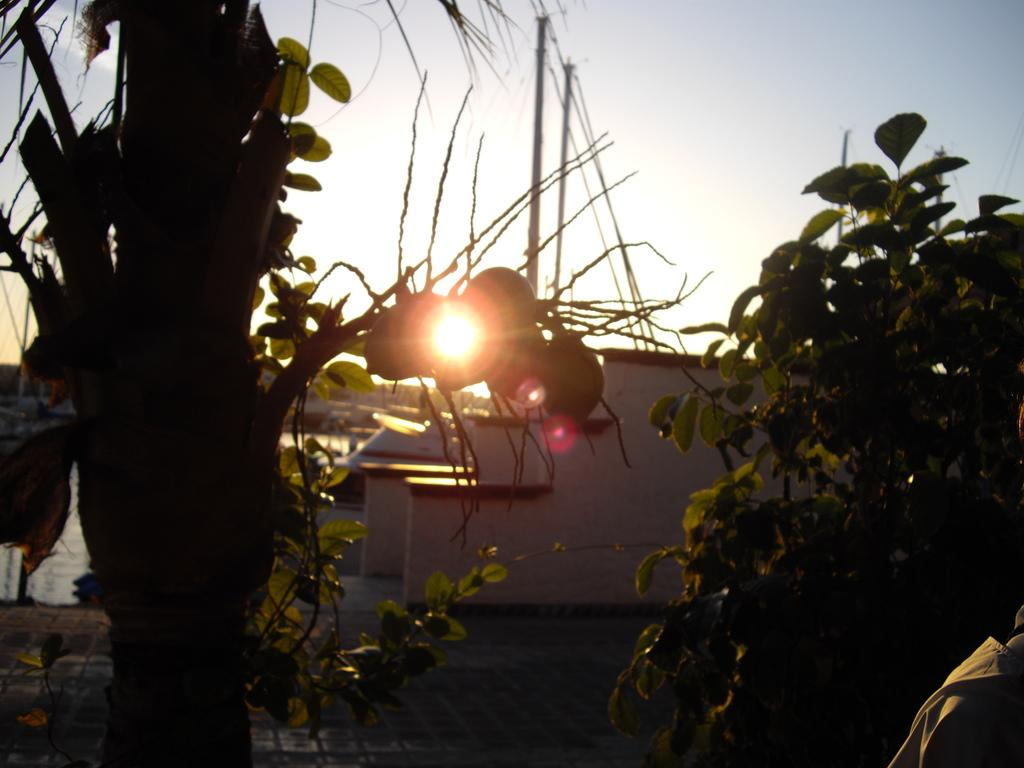How many trees can be seen in the image? There are two trees in the image. What type of structure is present in the image? There is a building in the image. What celestial body is visible in the image? The sun is visible in the image. What is visible at the top of the image? There is sky at the top of the image. Where is the vase located in the image? There is no vase present in the image. What type of nut is visible in the image? There are no nuts visible in the image. 